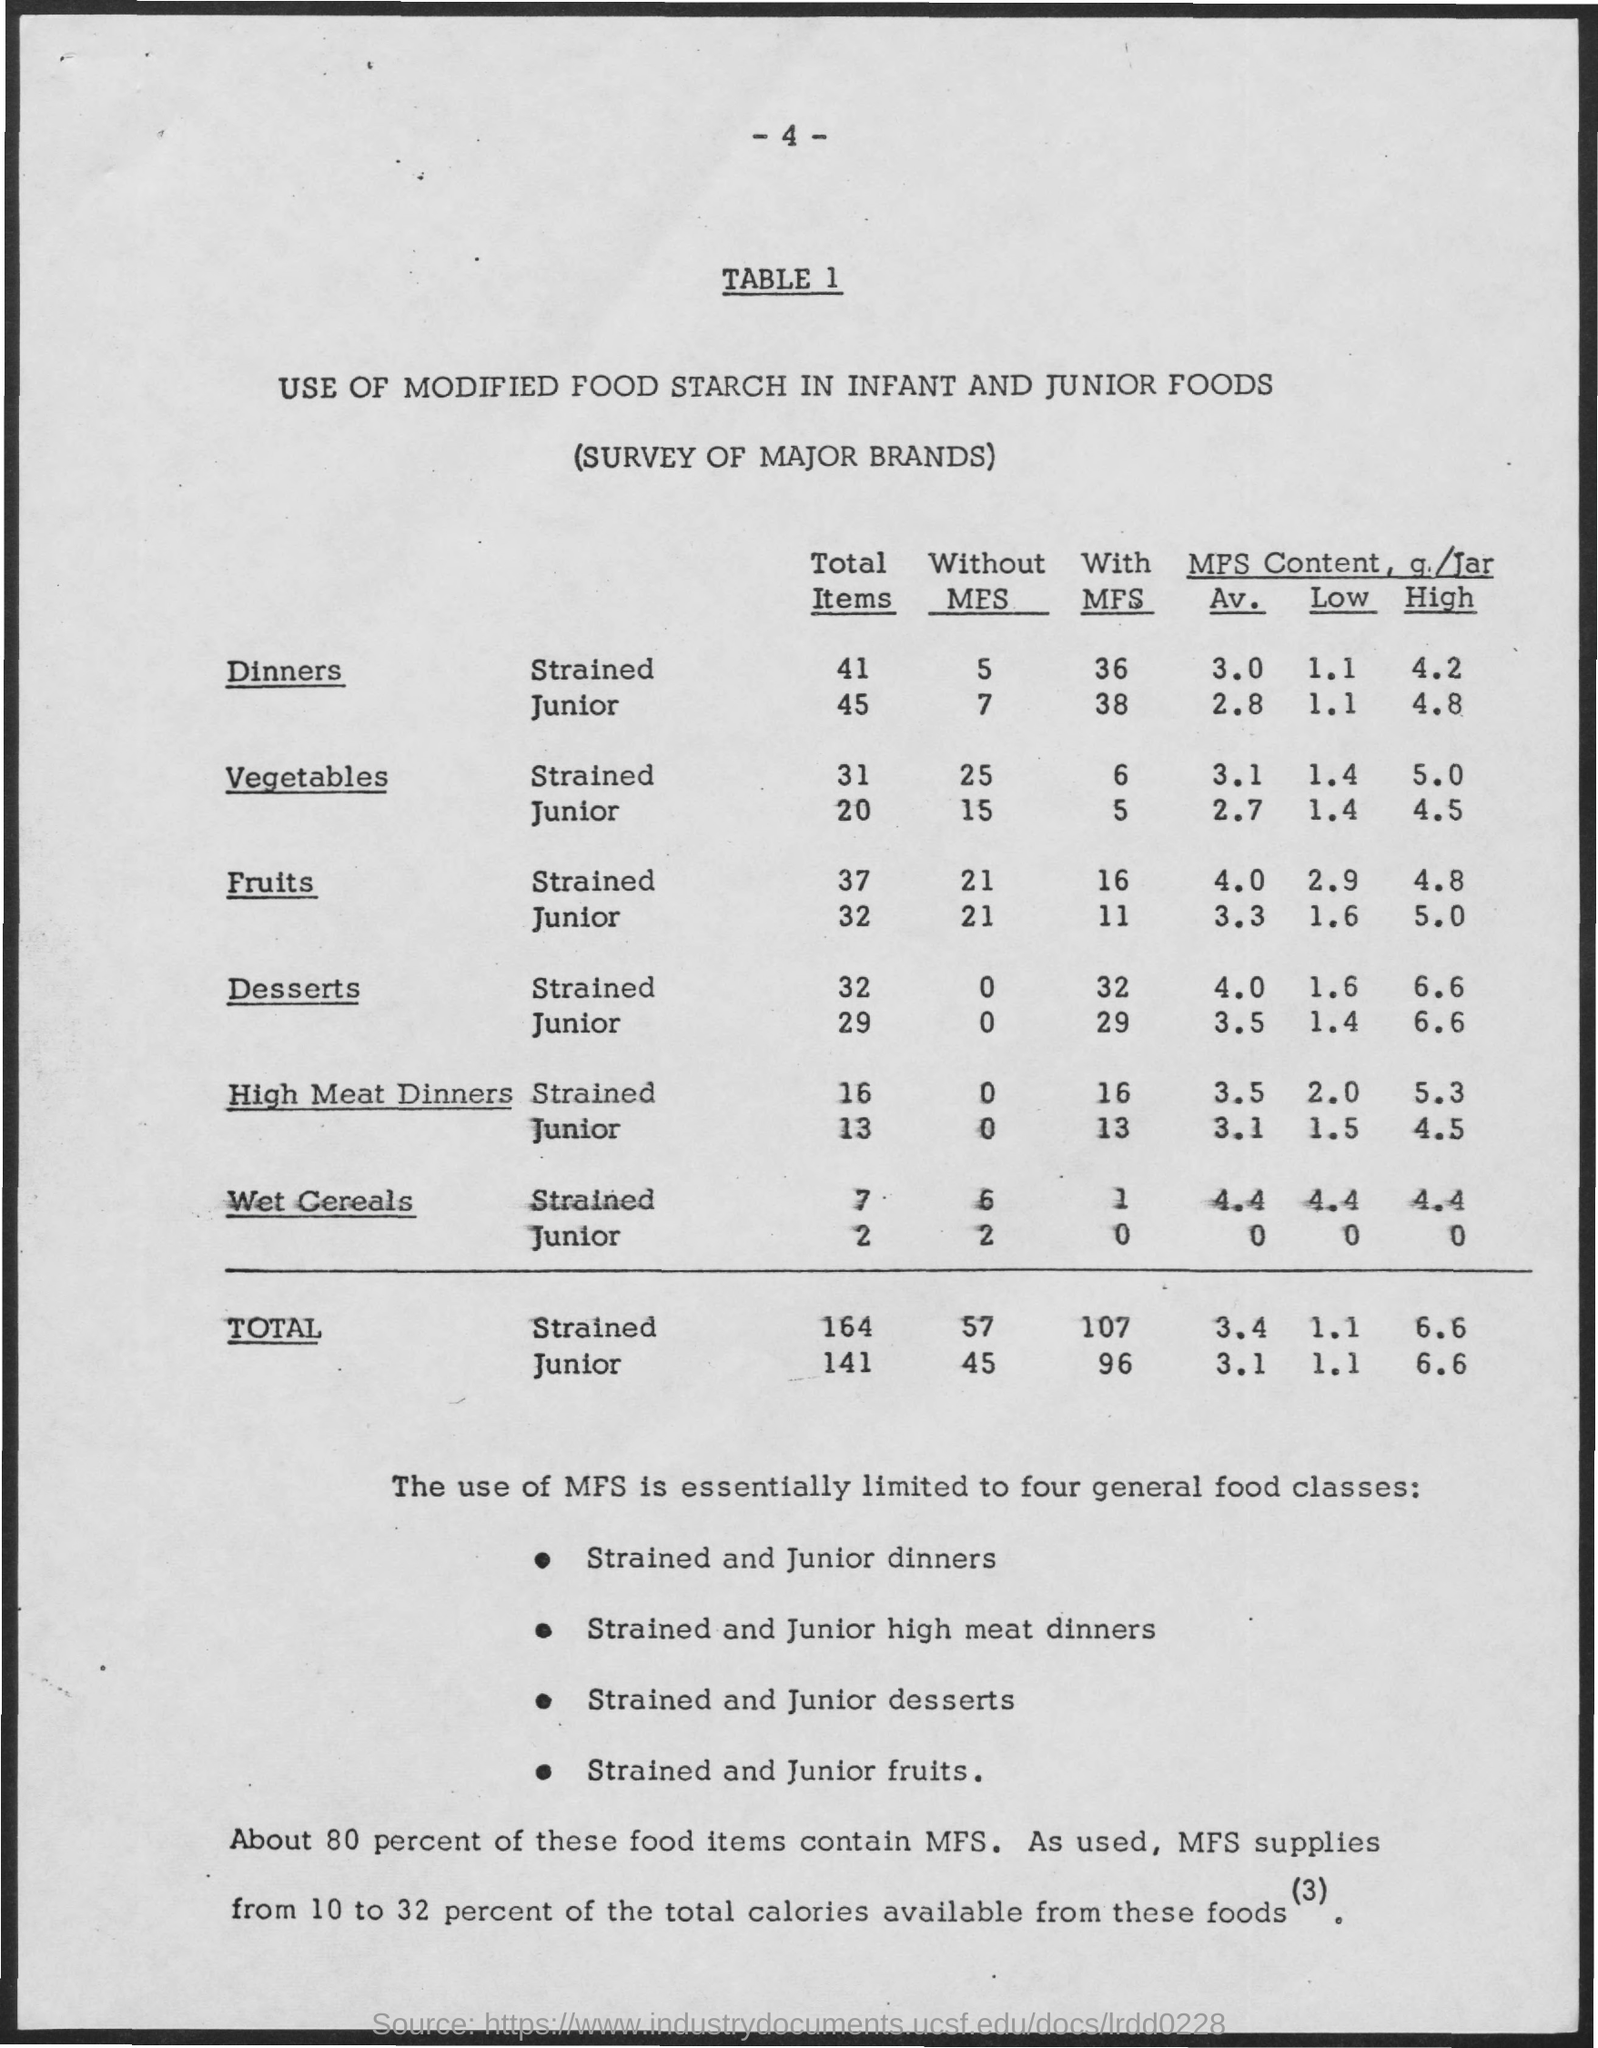What are the Total Items for "Strained" Dinners?
Your answer should be very brief. 41. What are the Total Items for "Junior" Dinners?
Give a very brief answer. 45. What are the "Without MFS" for "Strained" Dinners?
Give a very brief answer. 5. What are the "Without MFS" for "Junior" Dinners?
Your answer should be very brief. 7. What are the "With MFS" for "Strained" Dinners?
Keep it short and to the point. 36. What are the "With MFS" for "Junior" Dinners?
Offer a very short reply. 38. What are the "With MFS" for "Strained" Vegetables?
Offer a very short reply. 6. What are the "With MFS" for "Junior" Vegetables?
Make the answer very short. 5. What are the "Without MFS" for "Strained" Vegetables?
Make the answer very short. 25. What are the "Without MFS" for "Junior" Vegetables?
Provide a short and direct response. 15. 